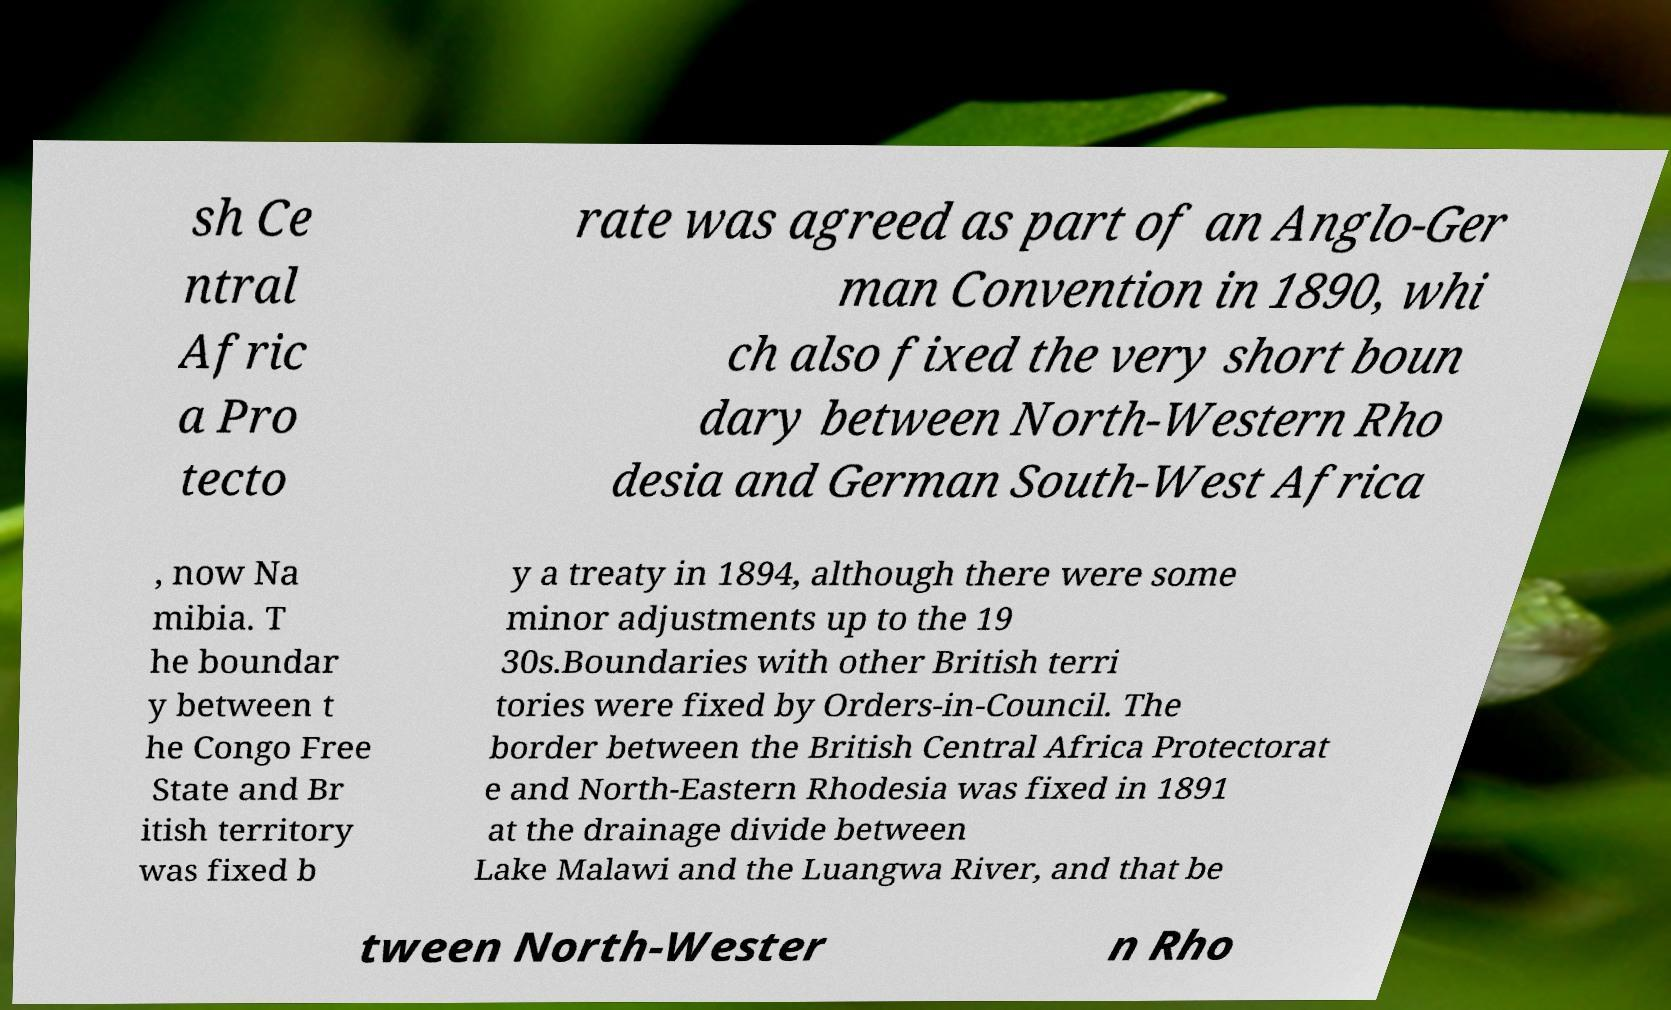Can you read and provide the text displayed in the image?This photo seems to have some interesting text. Can you extract and type it out for me? sh Ce ntral Afric a Pro tecto rate was agreed as part of an Anglo-Ger man Convention in 1890, whi ch also fixed the very short boun dary between North-Western Rho desia and German South-West Africa , now Na mibia. T he boundar y between t he Congo Free State and Br itish territory was fixed b y a treaty in 1894, although there were some minor adjustments up to the 19 30s.Boundaries with other British terri tories were fixed by Orders-in-Council. The border between the British Central Africa Protectorat e and North-Eastern Rhodesia was fixed in 1891 at the drainage divide between Lake Malawi and the Luangwa River, and that be tween North-Wester n Rho 